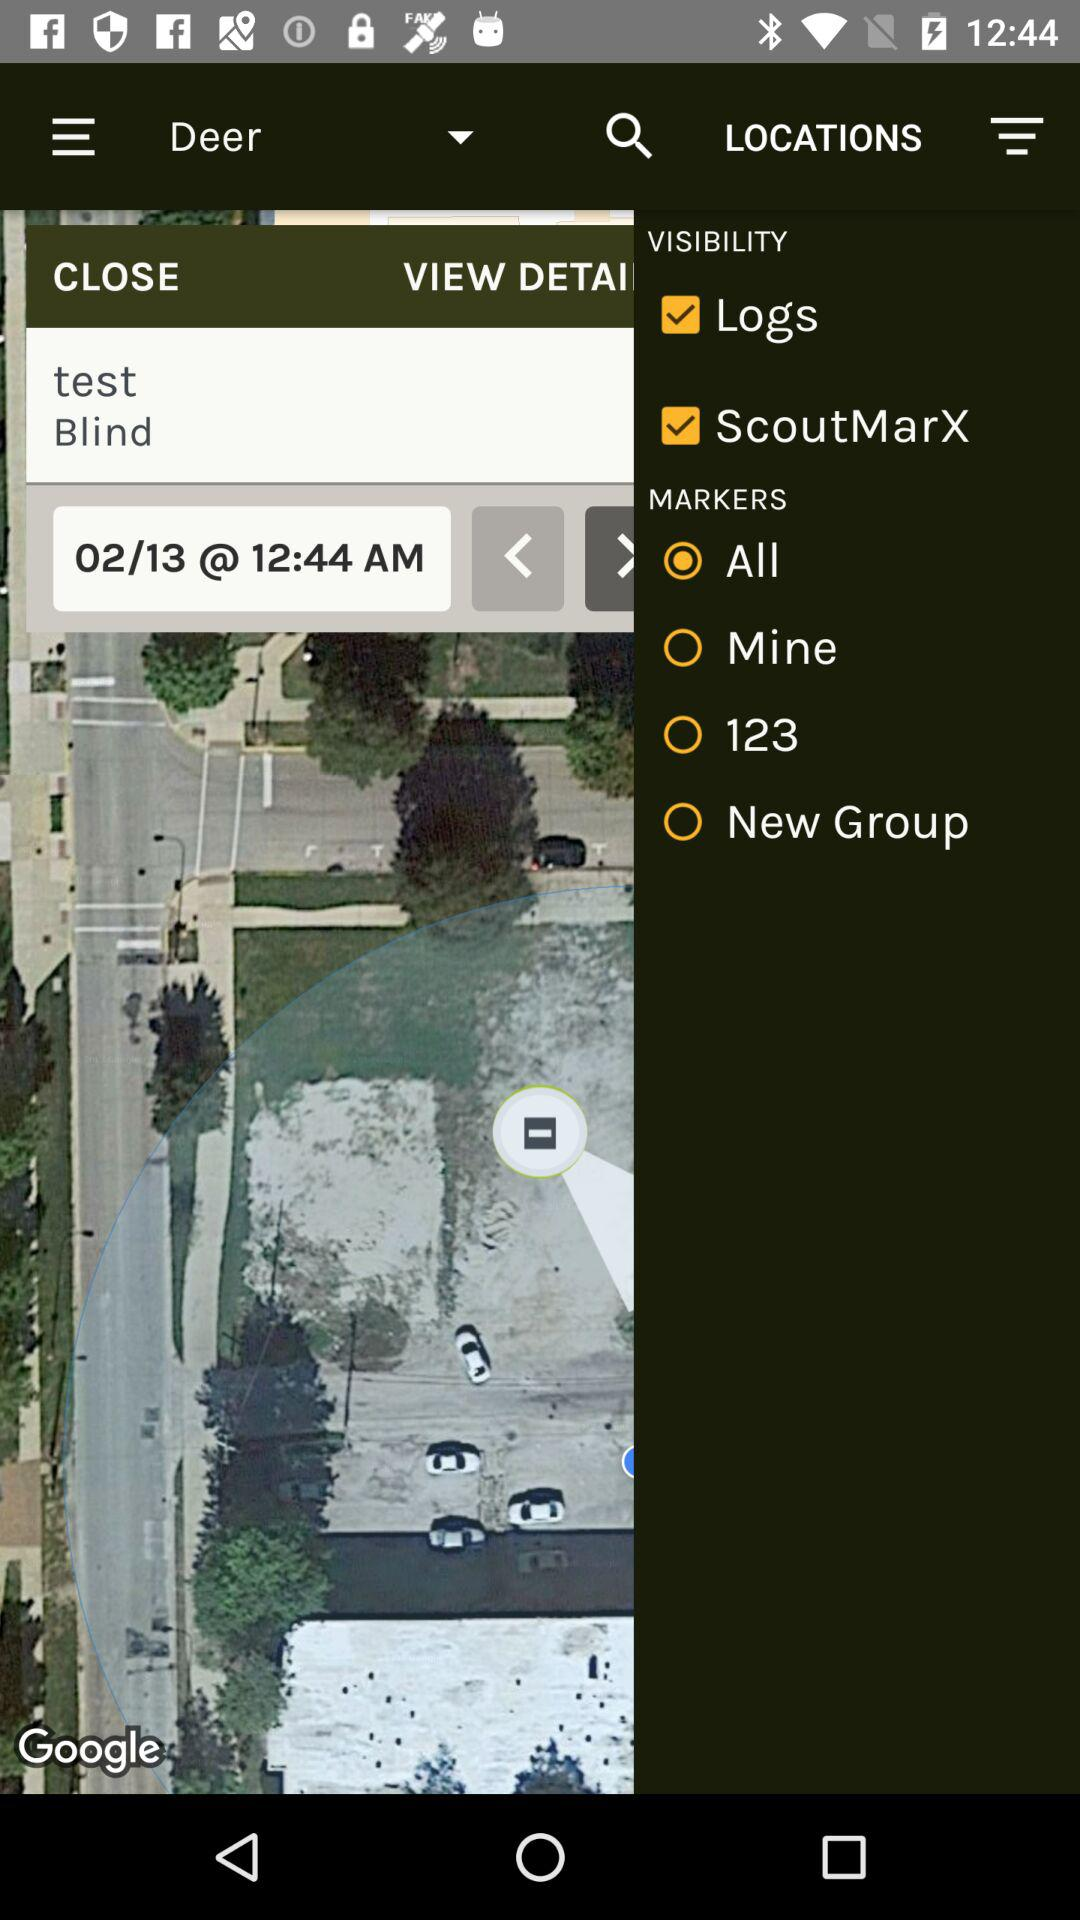What is the time? The time is 12:44 AM. 